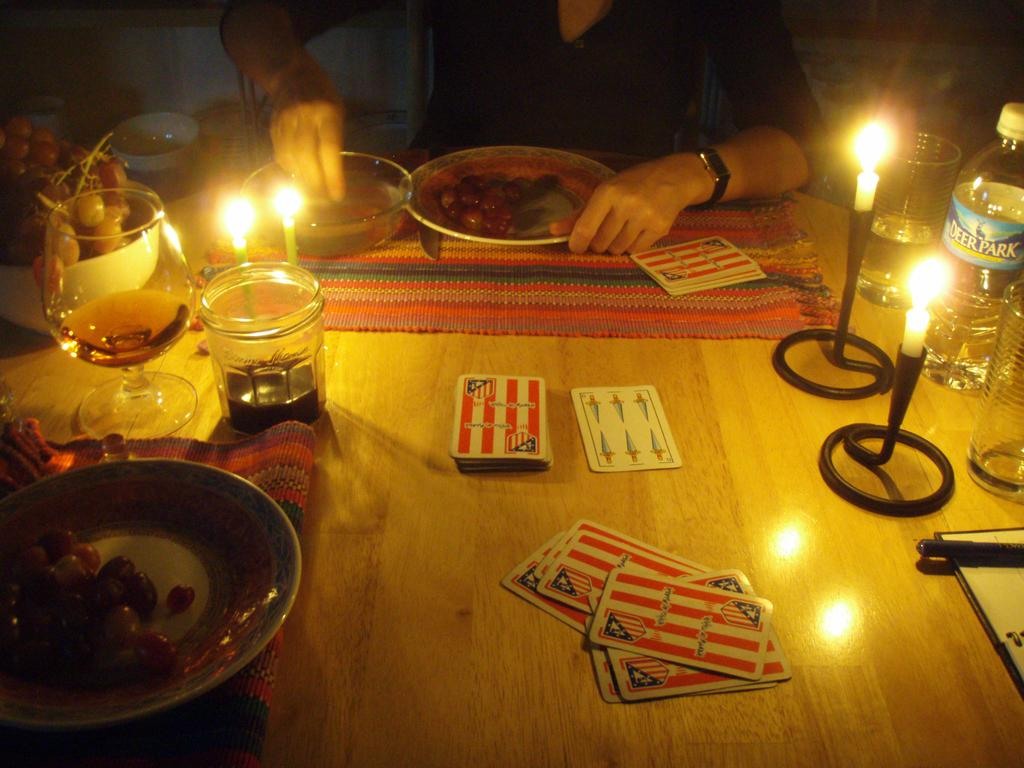What is the person in the image doing? The person is sitting beside a table. What objects can be seen on the table in the image? On the table, there is a plate, a bowl, a glass, a jar, cards, a candle, a bottle, fruits, and some food. What type of love can be seen in the image? There is no love present in the image; it features a person sitting beside a table with various objects. What kind of structure is depicted in the image? The image does not show any structure; it focuses on a person sitting beside a table with various objects. 